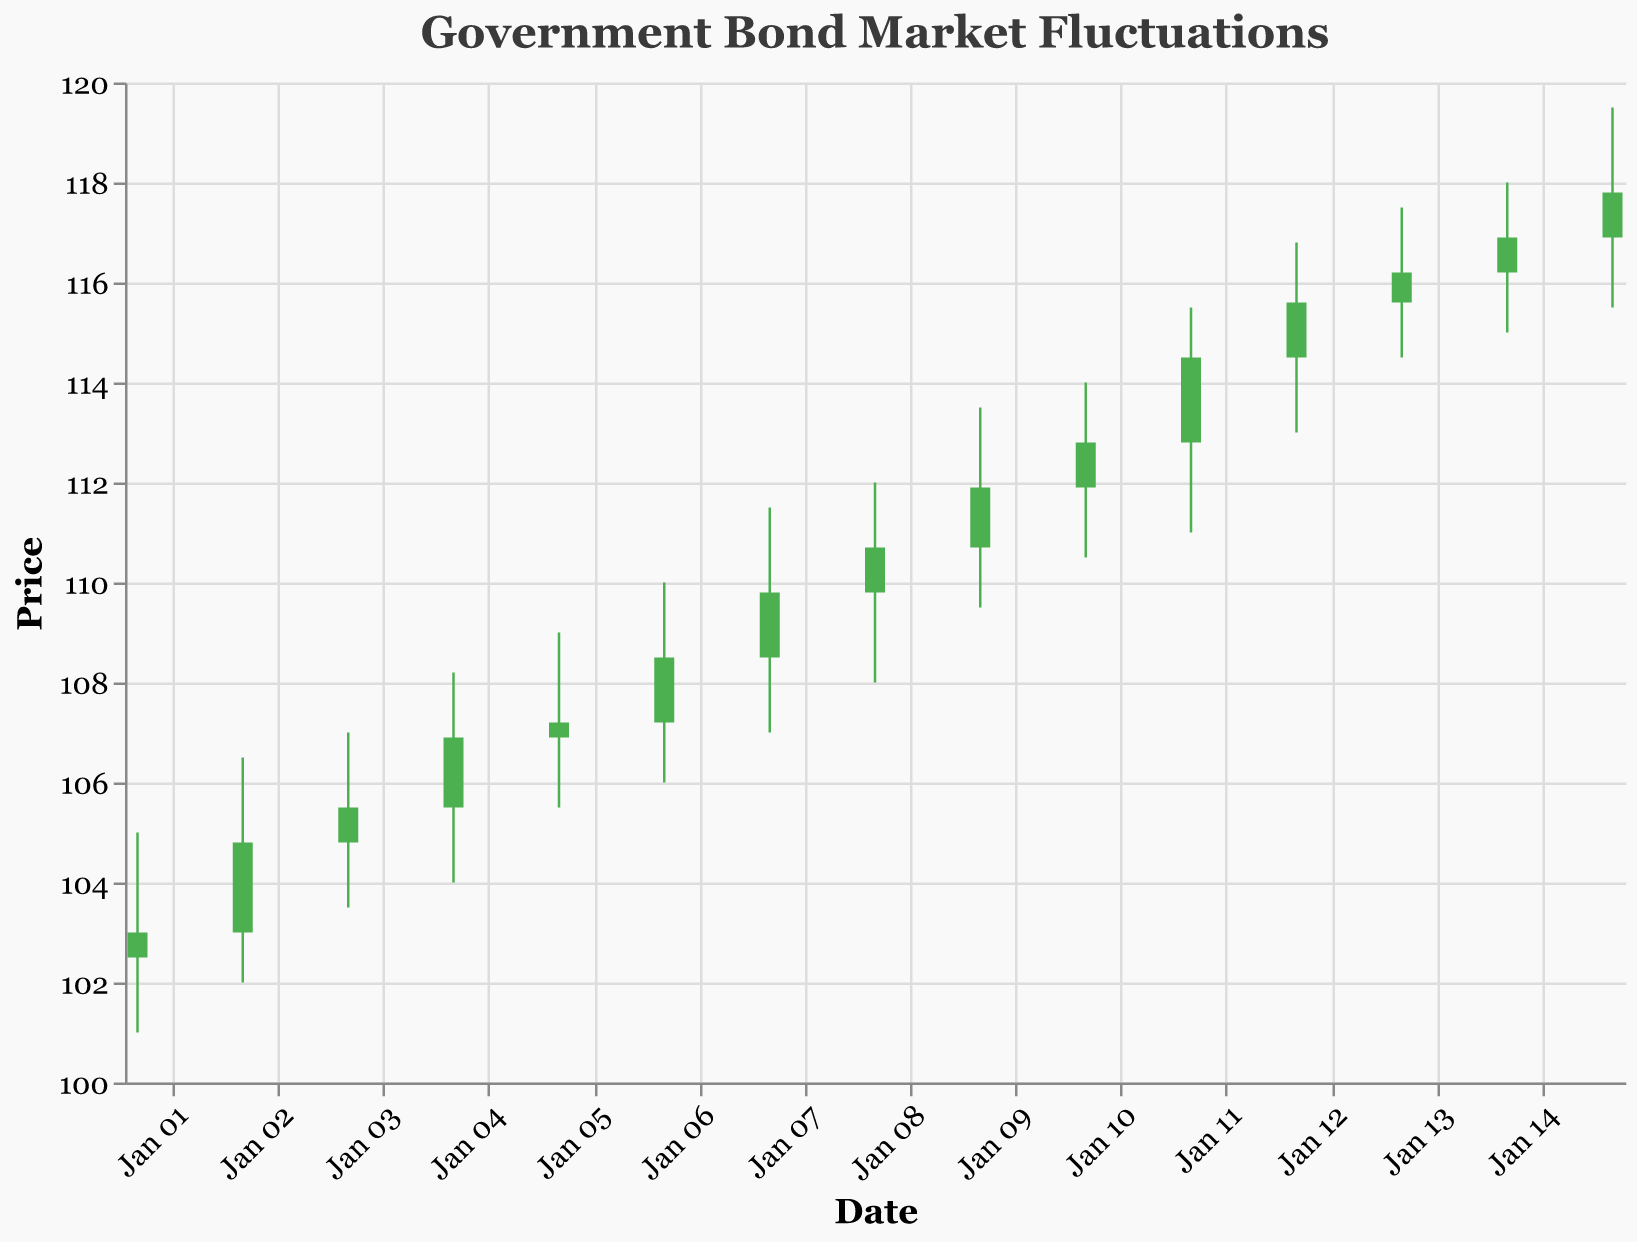What is the title of the figure? The title of a figure is typically found at the top and provides a description of what the figure is about. In this case, the title is "Government Bond Market Fluctuations."
Answer: Government Bond Market Fluctuations How many days of data are shown in the figure? To determine the number of days of data, count the number of dates listed. Each date represents one day of stock price information. In this dataset, the range is from January 1st to January 15th, giving us 15 days.
Answer: 15 On which date did the highest price occur, and what was it? Look for the highest value under the "High" column across all dates. The highest price is 119.50, which occurred on January 15th.
Answer: January 15th, 119.50 What is the trend in closing prices from January 1st to January 15th? Observe the closing prices from January 1st to January 15th. The trend can be seen as an overall increase as the closing price on January 1st is 103.00 and it climbs to 117.80 by January 15th.
Answer: Increasing Which days had a closing price higher than their opening price? Identify the days where the closing price is higher than the opening price. Those days include January 1st, 2nd, 4th, 5th, 6th, 7th, 9th, 10th, 11th, 12th, 13th, and 15th. Each of these days will have green candlesticks.
Answer: January 1, 2, 4, 5, 6, 7, 9, 10, 11, 12, 13, 15 On which day was the volume traded the highest, and what was the volume? To determine the highest volume traded, look for the highest value in the "Volume" column. The highest volume traded was 69,000 on January 15th.
Answer: January 15th, 69000 Which day showed the biggest difference between the high and low prices, and what was the difference? Find the day with the largest range by subtracting the low price from the high price for each day. The biggest difference is 4.50, which happened on January 9th (high of 113.50 and low of 109.50).
Answer: January 9th, 4.50 Between January 1st and January 15th, what was the average closing price? To find the average closing price, sum all the closing prices and divide by the number of days (15). Sum: 103.00 + 104.80 + 105.50 + 106.90 + 107.20 + 108.50 + 109.80 + 110.70 + 111.90 + 112.80 + 114.50 + 115.60 + 116.20 + 116.90 + 117.80 = 1656.10. The average is 1656.10 / 15 = 110.41.
Answer: 110.41 Which candlestick has the smallest body, and what is the difference between the open and close prices on that day? The smallest body of a candlestick is found by calculating the difference between the open and close prices and finding the smallest value. The smallest difference occurs on January 14th with a difference of 0.70 (open 116.20, close 116.90).
Answer: January 14th, 0.70 How many dates have red candlesticks, and what does a red candlestick indicate? Red candlesticks indicate that the closing price was lower than the opening price. Count the dates with red candlesticks. They are January 3rd, 8th, and 14th.
Answer: 3, A red candlestick indicates that the closing price was lower than the opening price 